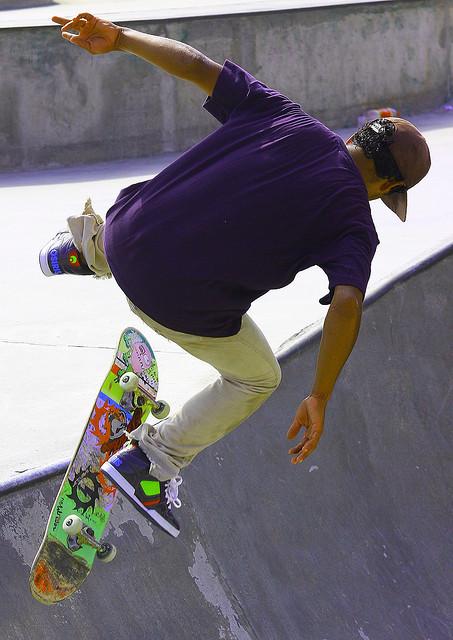What is this trick called?
Give a very brief answer. Ollie. Is he wearing a hat?
Quick response, please. Yes. What color are his pants?
Be succinct. Green. 